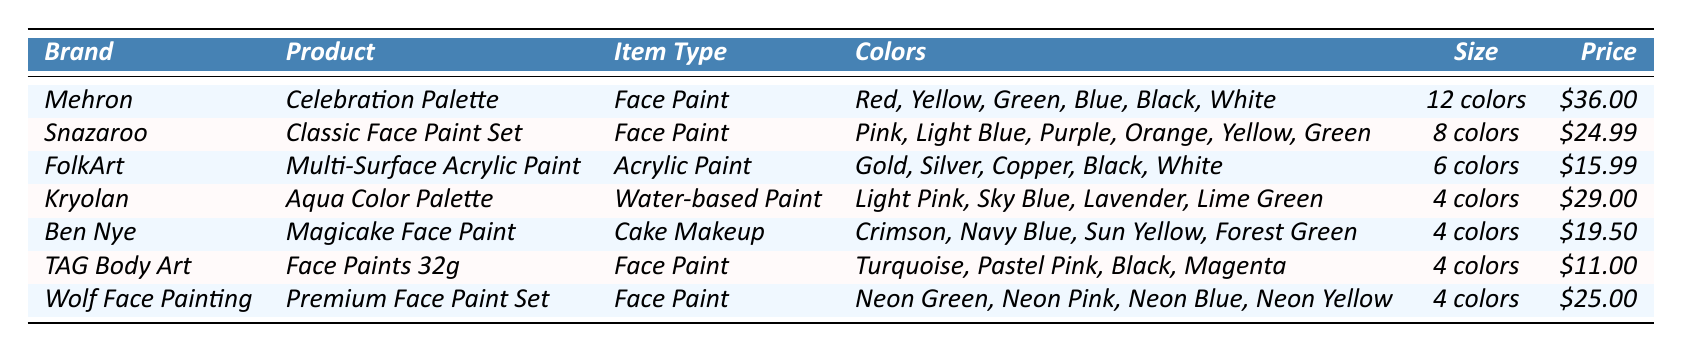What is the most expensive face paint in the inventory? The table shows the prices of each face paint. Scanning through the prices, Mehron's Celebration Palette is listed at $36.00, which is the highest price compared to others.
Answer: $36.00 How many colors are included in Snazaroo's Classic Face Paint Set? Looking at the table, the item size for Snazaroo's Classic Face Paint Set indicates that it includes 8 colors.
Answer: 8 colors Which brands offer face paint in a 4 color set? By comparing the table, both Kryolan (Aqua Color Palette) and TAG Body Art (Face Paints 32g) offer products that contain 4 colors.
Answer: Kryolan and TAG Body Art Is FolkArt's Multi-Surface Acrylic Paint more expensive than Ben Nye's Magicake Face Paint? The table lists FolkArt's price at $15.99 and Ben Nye's price at $19.50. Since $15.99 is less than $19.50, FolkArt's paint is less expensive.
Answer: No What is the average number of colors offered across all products? Count the total colors in each product (12 + 8 + 6 + 4 + 4 + 4 + 4 = 42 colors) and divide by the number of products (7). The average is 42 / 7 = 6.
Answer: 6 colors Are there any face paint products that include neon colors? Checking the colors listed for each product, Wolf Face Painting's Premium Face Paint Set includes Neon Green, Neon Pink, Neon Blue, and Neon Yellow. So yes, there are neon colors available.
Answer: Yes Which product has the lowest price, and what is the price? The table shows that TAG Body Art's Face Paints 32g is priced at $11.00, which is the lowest compared to other products.
Answer: $11.00 How much more does the Mehron Celebration Palette cost than the TAG Body Art Face Paints 32g? The price of Mehron is $36.00 and TAG Body Art's is $11.00. Subtract the lower price from the higher price: $36.00 - $11.00 = $25.00.
Answer: $25.00 What item types are represented in the inventory? By looking at the table, the item types include Face Paint, Acrylic Paint, and Cake Makeup, as shown in the respective rows.
Answer: Face Paint, Acrylic Paint, Cake Makeup Which brand offers a product with only 4 colors at a price of $19.50? The table indicates that Ben Nye's Magicake Face Paint is priced at $19.50 and includes 4 colors.
Answer: Ben Nye 